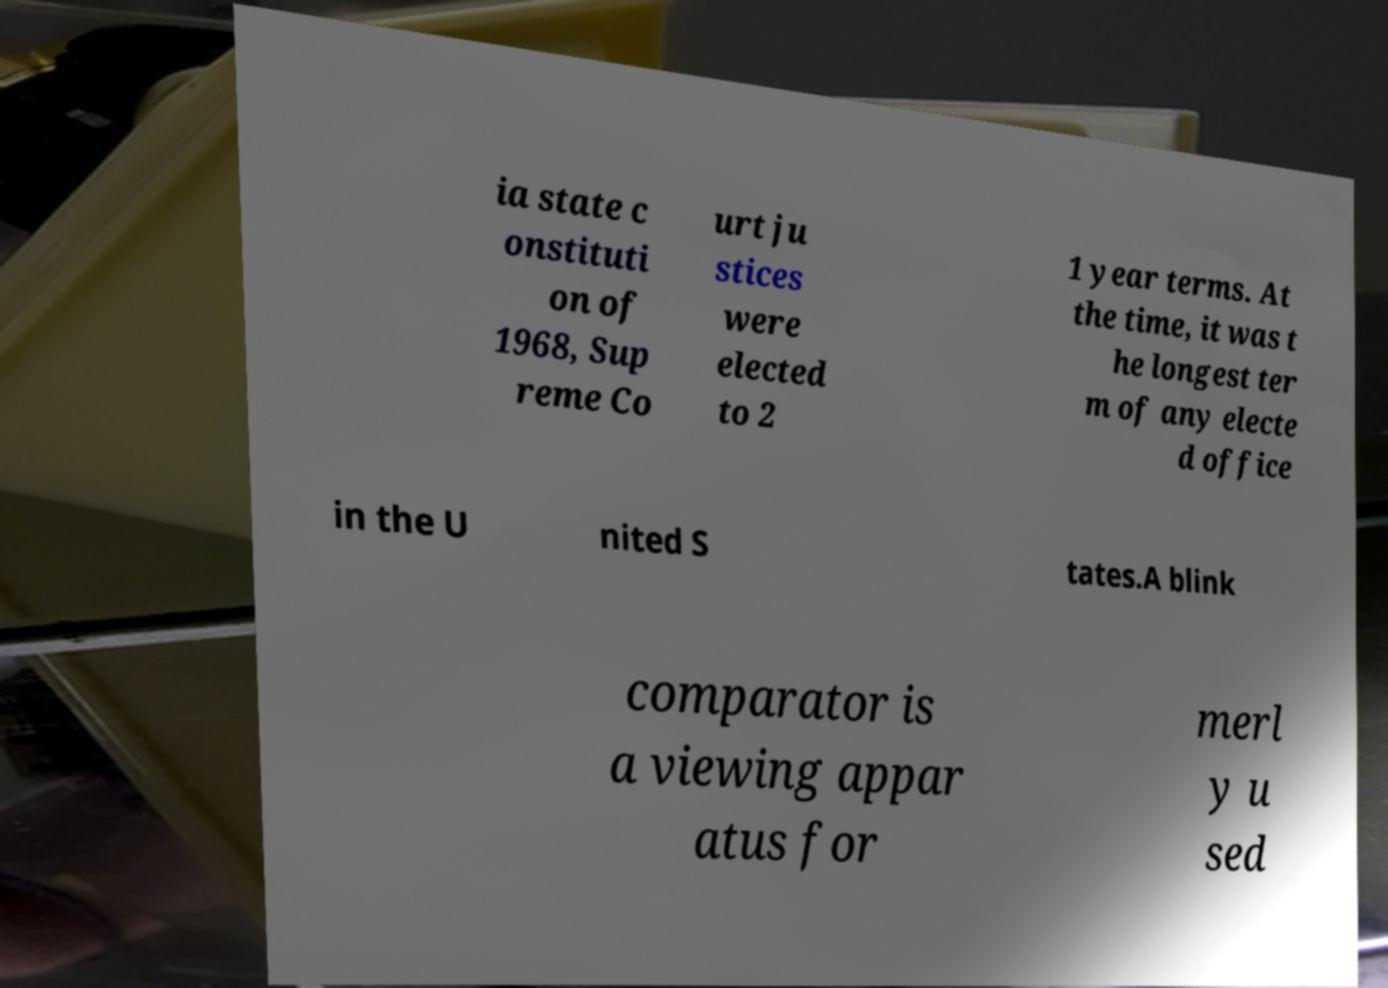What messages or text are displayed in this image? I need them in a readable, typed format. ia state c onstituti on of 1968, Sup reme Co urt ju stices were elected to 2 1 year terms. At the time, it was t he longest ter m of any electe d office in the U nited S tates.A blink comparator is a viewing appar atus for merl y u sed 